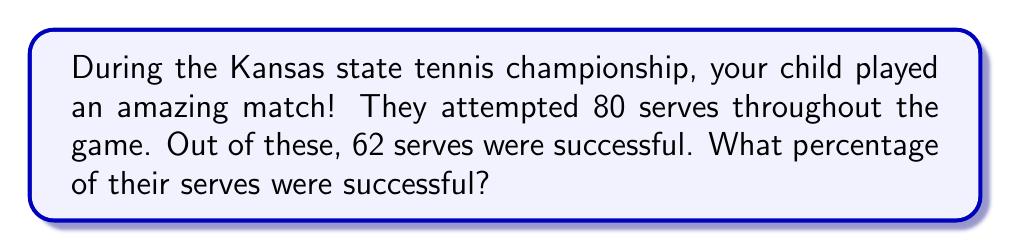Help me with this question. Let's break this down step-by-step:

1. First, we need to understand what percentage means. A percentage is a way of expressing a number as a fraction of 100.

2. To calculate a percentage, we use the following formula:

   $$ \text{Percentage} = \frac{\text{Part}}{\text{Whole}} \times 100\% $$

3. In this case:
   - The "Part" is the number of successful serves: 62
   - The "Whole" is the total number of serve attempts: 80

4. Let's plug these numbers into our formula:

   $$ \text{Percentage of successful serves} = \frac{62}{80} \times 100\% $$

5. Now, let's solve this step-by-step:
   
   $\frac{62}{80} = 0.775$

   $0.775 \times 100\% = 77.5\%$

Therefore, the percentage of successful serves is 77.5%.
Answer: 77.5% 